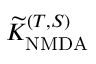Convert formula to latex. <formula><loc_0><loc_0><loc_500><loc_500>\widetilde { K } _ { N M D A } ^ { ( T , S ) }</formula> 